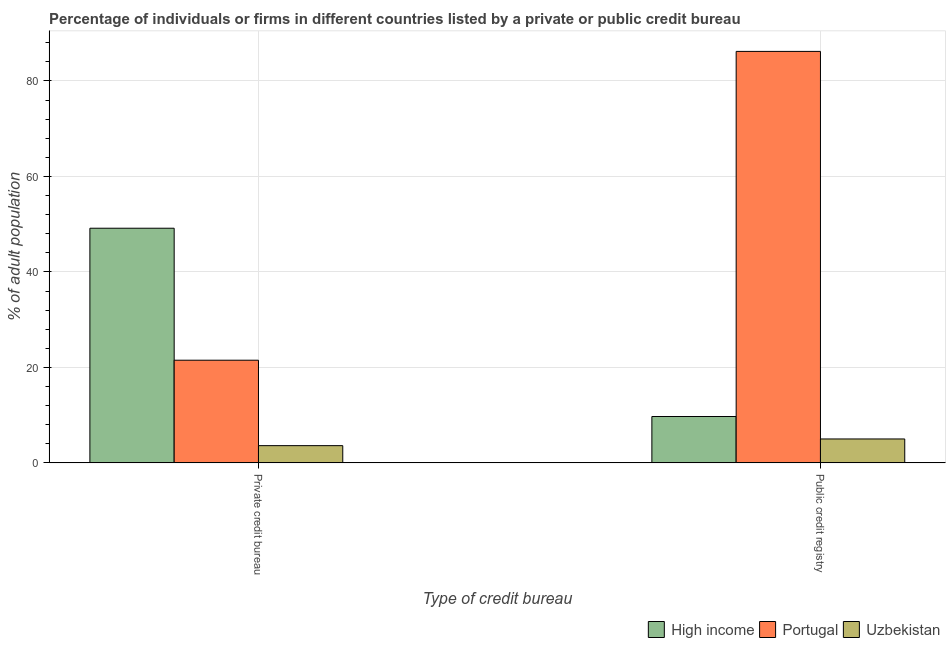How many different coloured bars are there?
Your answer should be very brief. 3. What is the label of the 1st group of bars from the left?
Offer a very short reply. Private credit bureau. What is the percentage of firms listed by public credit bureau in High income?
Provide a succinct answer. 9.71. Across all countries, what is the maximum percentage of firms listed by private credit bureau?
Ensure brevity in your answer.  49.15. Across all countries, what is the minimum percentage of firms listed by private credit bureau?
Make the answer very short. 3.6. In which country was the percentage of firms listed by public credit bureau minimum?
Your answer should be compact. Uzbekistan. What is the total percentage of firms listed by public credit bureau in the graph?
Offer a very short reply. 100.91. What is the difference between the percentage of firms listed by private credit bureau in Portugal and that in High income?
Your answer should be very brief. -27.65. What is the difference between the percentage of firms listed by private credit bureau in Portugal and the percentage of firms listed by public credit bureau in Uzbekistan?
Ensure brevity in your answer.  16.5. What is the average percentage of firms listed by private credit bureau per country?
Your response must be concise. 24.75. What is the difference between the percentage of firms listed by public credit bureau and percentage of firms listed by private credit bureau in High income?
Your response must be concise. -39.45. In how many countries, is the percentage of firms listed by public credit bureau greater than 76 %?
Provide a succinct answer. 1. What is the ratio of the percentage of firms listed by public credit bureau in High income to that in Portugal?
Your answer should be compact. 0.11. In how many countries, is the percentage of firms listed by public credit bureau greater than the average percentage of firms listed by public credit bureau taken over all countries?
Provide a short and direct response. 1. What does the 3rd bar from the left in Public credit registry represents?
Provide a succinct answer. Uzbekistan. How many bars are there?
Provide a succinct answer. 6. What is the difference between two consecutive major ticks on the Y-axis?
Offer a very short reply. 20. Does the graph contain any zero values?
Make the answer very short. No. What is the title of the graph?
Offer a very short reply. Percentage of individuals or firms in different countries listed by a private or public credit bureau. Does "New Zealand" appear as one of the legend labels in the graph?
Your answer should be compact. No. What is the label or title of the X-axis?
Give a very brief answer. Type of credit bureau. What is the label or title of the Y-axis?
Provide a short and direct response. % of adult population. What is the % of adult population of High income in Private credit bureau?
Keep it short and to the point. 49.15. What is the % of adult population in Portugal in Private credit bureau?
Provide a succinct answer. 21.5. What is the % of adult population in Uzbekistan in Private credit bureau?
Give a very brief answer. 3.6. What is the % of adult population in High income in Public credit registry?
Your response must be concise. 9.71. What is the % of adult population in Portugal in Public credit registry?
Your answer should be compact. 86.2. Across all Type of credit bureau, what is the maximum % of adult population of High income?
Your response must be concise. 49.15. Across all Type of credit bureau, what is the maximum % of adult population of Portugal?
Your answer should be very brief. 86.2. Across all Type of credit bureau, what is the minimum % of adult population in High income?
Provide a succinct answer. 9.71. Across all Type of credit bureau, what is the minimum % of adult population of Portugal?
Your answer should be very brief. 21.5. Across all Type of credit bureau, what is the minimum % of adult population in Uzbekistan?
Offer a very short reply. 3.6. What is the total % of adult population of High income in the graph?
Give a very brief answer. 58.86. What is the total % of adult population in Portugal in the graph?
Make the answer very short. 107.7. What is the total % of adult population of Uzbekistan in the graph?
Offer a terse response. 8.6. What is the difference between the % of adult population of High income in Private credit bureau and that in Public credit registry?
Provide a succinct answer. 39.45. What is the difference between the % of adult population of Portugal in Private credit bureau and that in Public credit registry?
Offer a terse response. -64.7. What is the difference between the % of adult population of High income in Private credit bureau and the % of adult population of Portugal in Public credit registry?
Your answer should be compact. -37.05. What is the difference between the % of adult population in High income in Private credit bureau and the % of adult population in Uzbekistan in Public credit registry?
Offer a terse response. 44.15. What is the average % of adult population in High income per Type of credit bureau?
Ensure brevity in your answer.  29.43. What is the average % of adult population in Portugal per Type of credit bureau?
Your answer should be compact. 53.85. What is the average % of adult population in Uzbekistan per Type of credit bureau?
Your answer should be compact. 4.3. What is the difference between the % of adult population in High income and % of adult population in Portugal in Private credit bureau?
Provide a succinct answer. 27.65. What is the difference between the % of adult population in High income and % of adult population in Uzbekistan in Private credit bureau?
Give a very brief answer. 45.55. What is the difference between the % of adult population in High income and % of adult population in Portugal in Public credit registry?
Your answer should be very brief. -76.49. What is the difference between the % of adult population of High income and % of adult population of Uzbekistan in Public credit registry?
Make the answer very short. 4.71. What is the difference between the % of adult population of Portugal and % of adult population of Uzbekistan in Public credit registry?
Your answer should be compact. 81.2. What is the ratio of the % of adult population of High income in Private credit bureau to that in Public credit registry?
Offer a terse response. 5.06. What is the ratio of the % of adult population of Portugal in Private credit bureau to that in Public credit registry?
Offer a terse response. 0.25. What is the ratio of the % of adult population in Uzbekistan in Private credit bureau to that in Public credit registry?
Give a very brief answer. 0.72. What is the difference between the highest and the second highest % of adult population in High income?
Offer a very short reply. 39.45. What is the difference between the highest and the second highest % of adult population in Portugal?
Give a very brief answer. 64.7. What is the difference between the highest and the second highest % of adult population of Uzbekistan?
Offer a terse response. 1.4. What is the difference between the highest and the lowest % of adult population in High income?
Make the answer very short. 39.45. What is the difference between the highest and the lowest % of adult population in Portugal?
Provide a succinct answer. 64.7. 